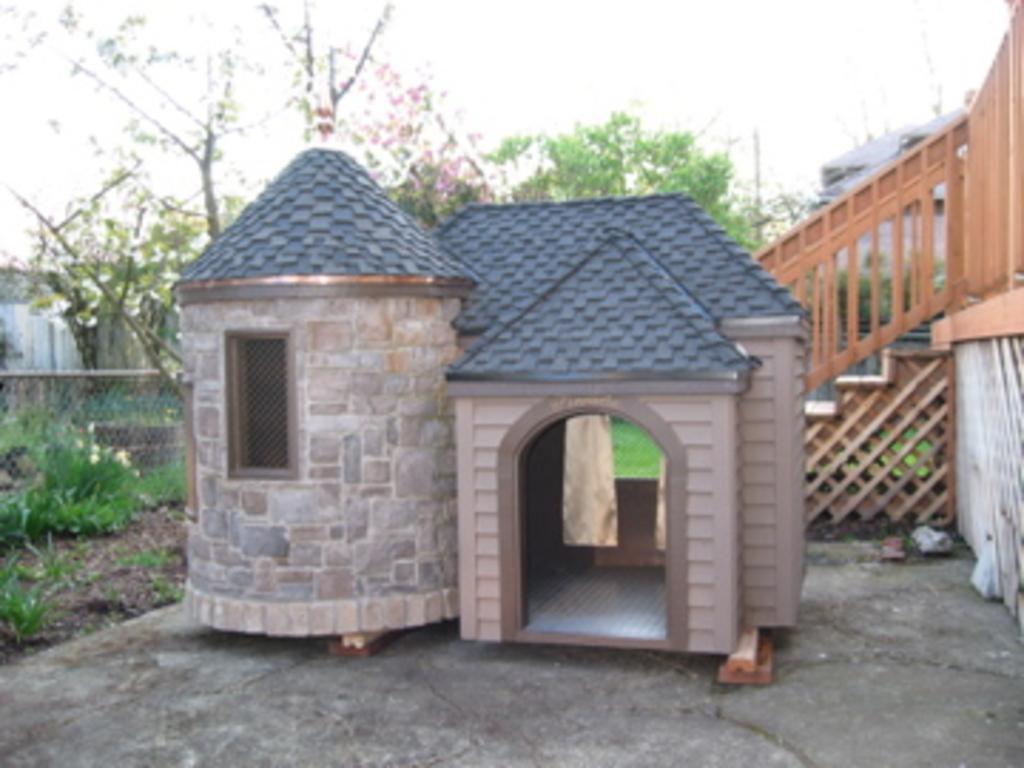Please provide a concise description of this image. In this picture there are buildings and trees. On the right side of the image there is a wooden staircase and wooden railing. In the foreground it looks like a wooden house. On the left side of the image there is a fence and there is a wall and there are plants. At the top there is sky. At the bottom there is a floor and there is ground. 